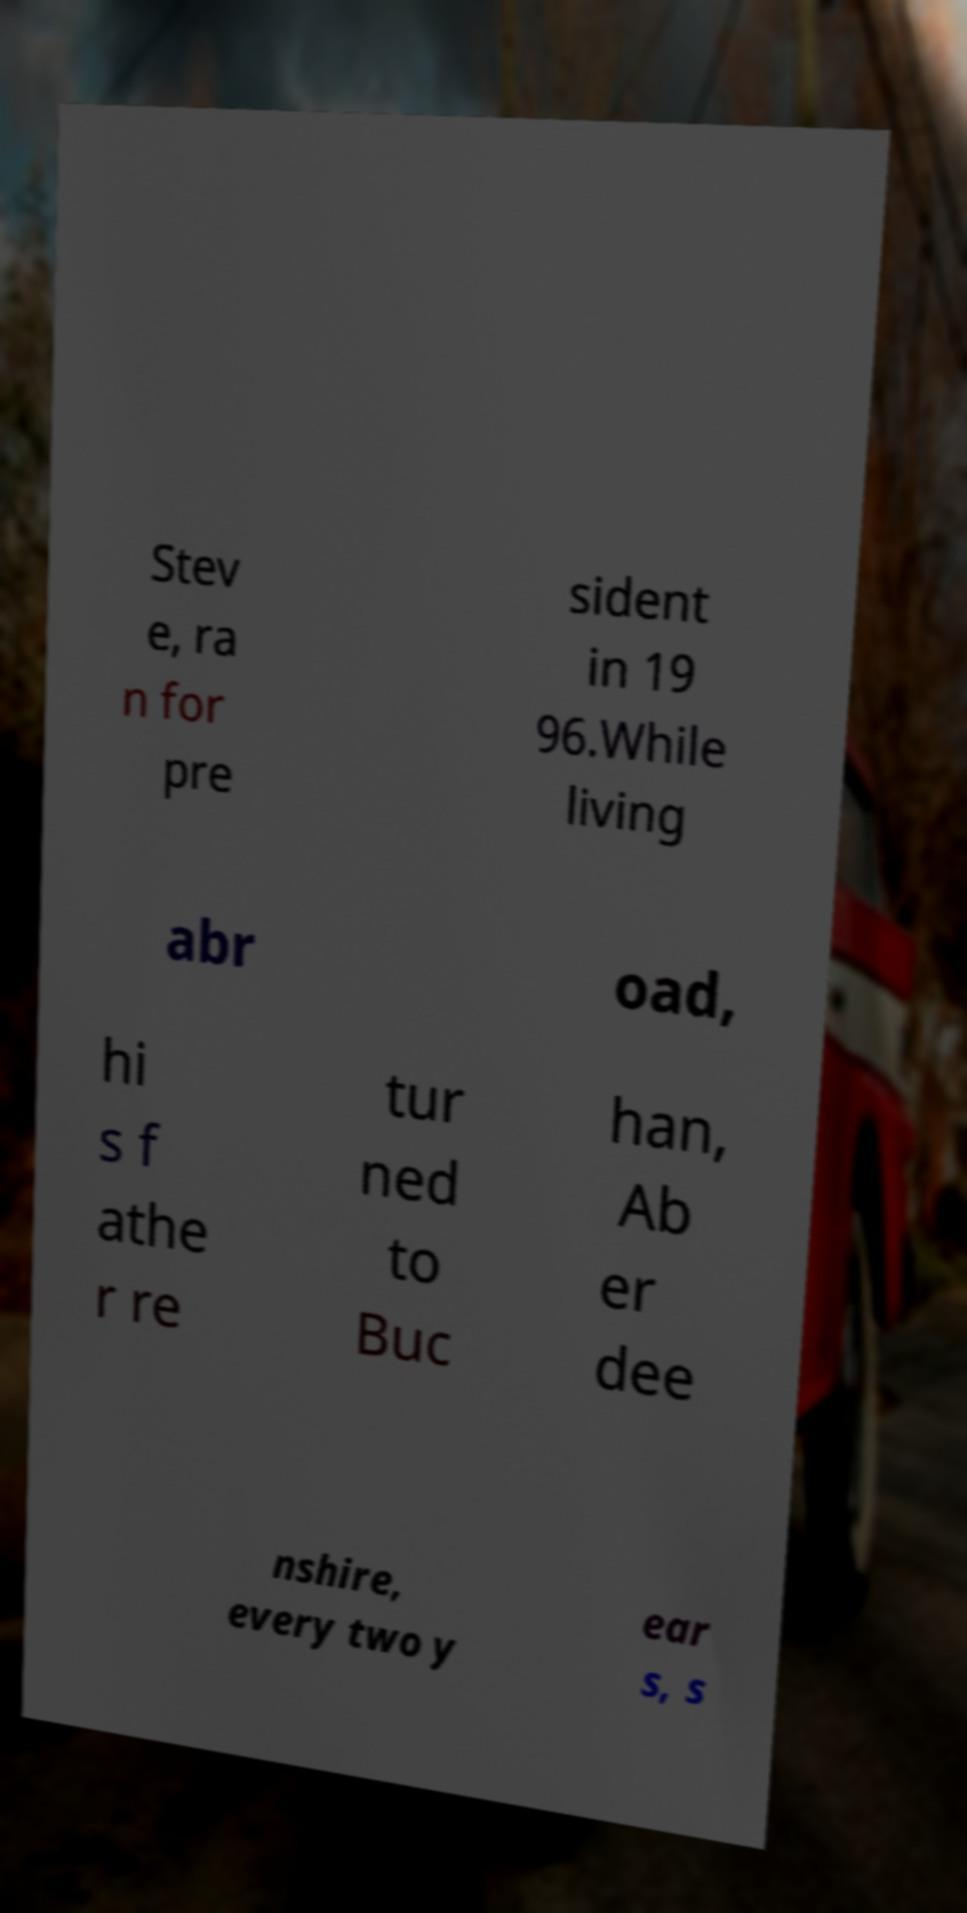Could you extract and type out the text from this image? Stev e, ra n for pre sident in 19 96.While living abr oad, hi s f athe r re tur ned to Buc han, Ab er dee nshire, every two y ear s, s 